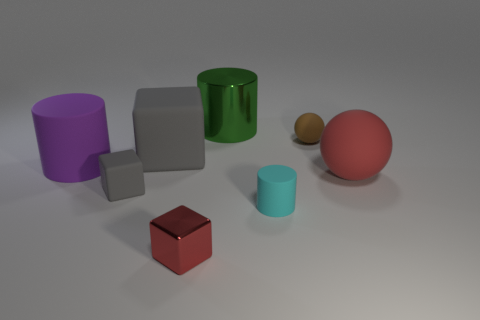Add 2 big gray cubes. How many objects exist? 10 Subtract all small matte cylinders. How many cylinders are left? 2 Subtract all red blocks. How many blocks are left? 2 Subtract all gray cubes. How many purple cylinders are left? 1 Subtract all cubes. How many objects are left? 5 Subtract 2 cylinders. How many cylinders are left? 1 Subtract all large gray things. Subtract all brown objects. How many objects are left? 6 Add 3 big green shiny objects. How many big green shiny objects are left? 4 Add 3 small blue metal blocks. How many small blue metal blocks exist? 3 Subtract 0 yellow blocks. How many objects are left? 8 